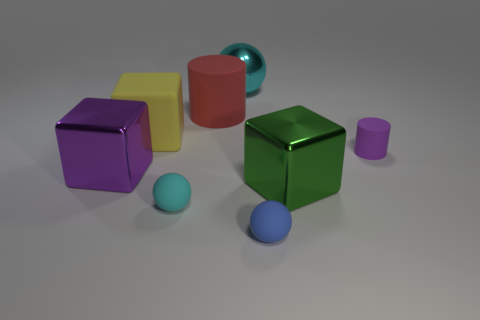What material is the small object behind the big green block?
Your response must be concise. Rubber. What is the large ball made of?
Ensure brevity in your answer.  Metal. The cylinder on the left side of the tiny matte object that is behind the big metallic cube that is left of the large yellow rubber object is made of what material?
Provide a succinct answer. Rubber. Are there any other things that are the same material as the purple block?
Your answer should be very brief. Yes. There is a yellow block; is it the same size as the purple object that is behind the large purple object?
Offer a terse response. No. How many things are tiny rubber objects to the right of the shiny ball or rubber things that are behind the small blue rubber sphere?
Make the answer very short. 5. There is a metallic object that is in front of the large purple metal block; what color is it?
Offer a very short reply. Green. There is a rubber ball in front of the tiny cyan ball; are there any cubes left of it?
Your answer should be very brief. Yes. Are there fewer big cylinders than big purple metal spheres?
Keep it short and to the point. No. What material is the big cube in front of the purple object in front of the purple rubber thing?
Provide a short and direct response. Metal. 